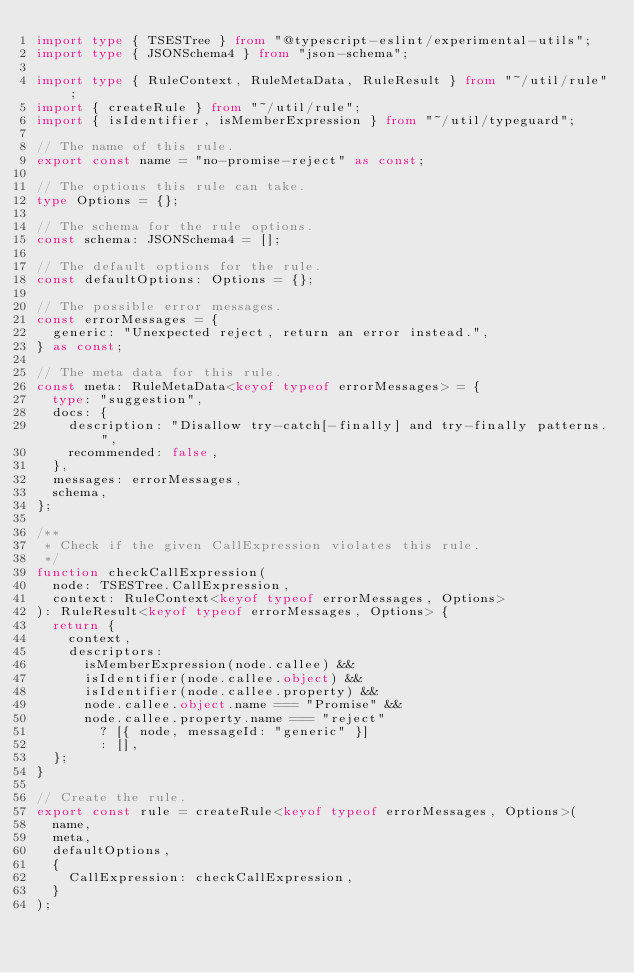<code> <loc_0><loc_0><loc_500><loc_500><_TypeScript_>import type { TSESTree } from "@typescript-eslint/experimental-utils";
import type { JSONSchema4 } from "json-schema";

import type { RuleContext, RuleMetaData, RuleResult } from "~/util/rule";
import { createRule } from "~/util/rule";
import { isIdentifier, isMemberExpression } from "~/util/typeguard";

// The name of this rule.
export const name = "no-promise-reject" as const;

// The options this rule can take.
type Options = {};

// The schema for the rule options.
const schema: JSONSchema4 = [];

// The default options for the rule.
const defaultOptions: Options = {};

// The possible error messages.
const errorMessages = {
  generic: "Unexpected reject, return an error instead.",
} as const;

// The meta data for this rule.
const meta: RuleMetaData<keyof typeof errorMessages> = {
  type: "suggestion",
  docs: {
    description: "Disallow try-catch[-finally] and try-finally patterns.",
    recommended: false,
  },
  messages: errorMessages,
  schema,
};

/**
 * Check if the given CallExpression violates this rule.
 */
function checkCallExpression(
  node: TSESTree.CallExpression,
  context: RuleContext<keyof typeof errorMessages, Options>
): RuleResult<keyof typeof errorMessages, Options> {
  return {
    context,
    descriptors:
      isMemberExpression(node.callee) &&
      isIdentifier(node.callee.object) &&
      isIdentifier(node.callee.property) &&
      node.callee.object.name === "Promise" &&
      node.callee.property.name === "reject"
        ? [{ node, messageId: "generic" }]
        : [],
  };
}

// Create the rule.
export const rule = createRule<keyof typeof errorMessages, Options>(
  name,
  meta,
  defaultOptions,
  {
    CallExpression: checkCallExpression,
  }
);
</code> 